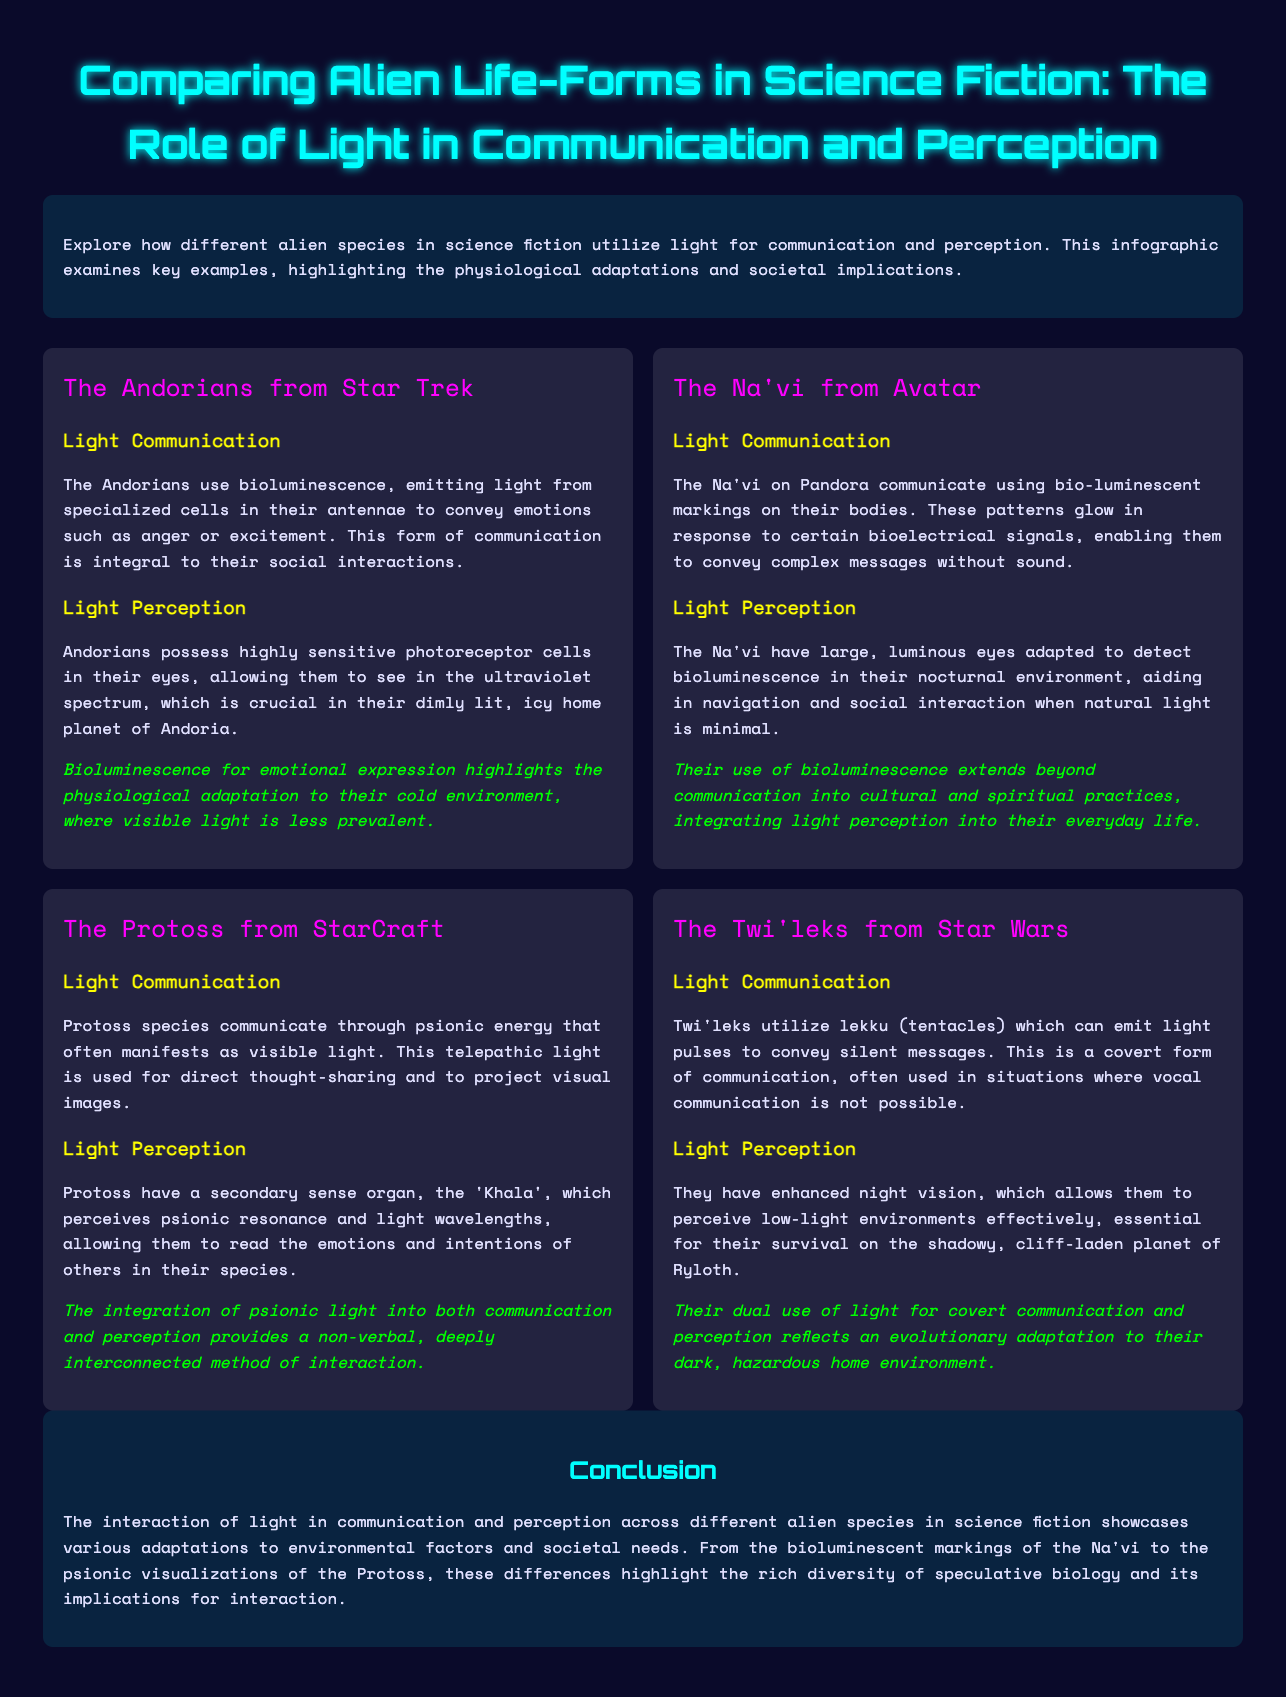what is the primary light communication method of the Andorians? The Andorians use bioluminescence, emitting light from specialized cells in their antennae to convey emotions such as anger or excitement.
Answer: bioluminescence how do the Na'vi perceive light in their environment? The Na'vi have large, luminous eyes adapted to detect bioluminescence in their nocturnal environment, aiding in navigation and social interaction when natural light is minimal.
Answer: large, luminous eyes what unique organ do the Protoss possess for light perception? Protoss have a secondary sense organ, the 'Khala', which perceives psionic resonance and light wavelengths.
Answer: Khala which alien species utilizes lekku for light communication? The Twi'leks utilize lekku (tentacles) which can emit light pulses to convey silent messages.
Answer: Twi'leks what societal aspect is highlighted in the communication of the Na'vi? Their use of bioluminescence extends beyond communication into cultural and spiritual practices, integrating light perception into their everyday life.
Answer: cultural and spiritual practices how is light used in communication by the Protoss? Protoss species communicate through psionic energy that often manifests as visible light.
Answer: psionic energy what is the common feature of light perception among the Andorians, Na'vi, and Protoss? All these species have adapted their visual systems to perceive light in a way that enhances their communication strategies.
Answer: enhanced visual systems what does the conclusion emphasize about light across different species? The conclusion emphasizes the diversity of adaptations to environmental factors and societal needs in the interaction of light across different alien species.
Answer: diversity of adaptations 